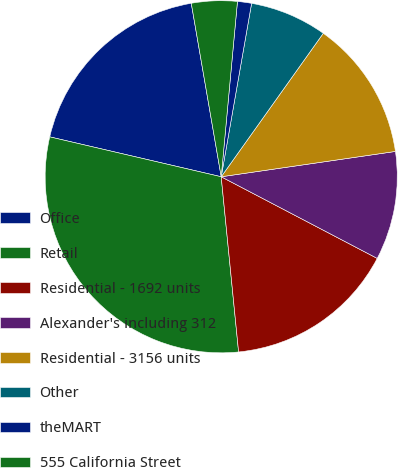<chart> <loc_0><loc_0><loc_500><loc_500><pie_chart><fcel>Office<fcel>Retail<fcel>Residential - 1692 units<fcel>Alexander's including 312<fcel>Residential - 3156 units<fcel>Other<fcel>theMART<fcel>555 California Street<nl><fcel>18.64%<fcel>30.21%<fcel>15.75%<fcel>9.97%<fcel>12.86%<fcel>7.08%<fcel>1.29%<fcel>4.19%<nl></chart> 